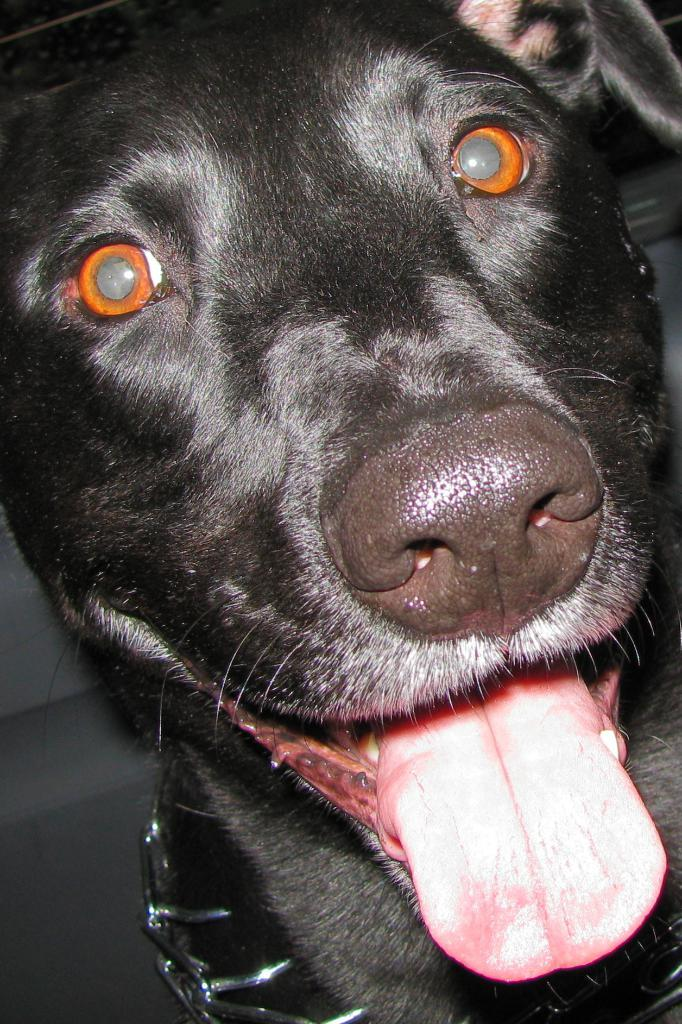What type of animal is in the image? There is a dog in the image. What is the dog doing with its tongue? The dog has its tongue out. Is there any accessory or object around the dog's neck? Yes, there is a belt around the dog's neck. What book is the dog reading in the image? There is no book present in the image, and dogs do not have the ability to read. 